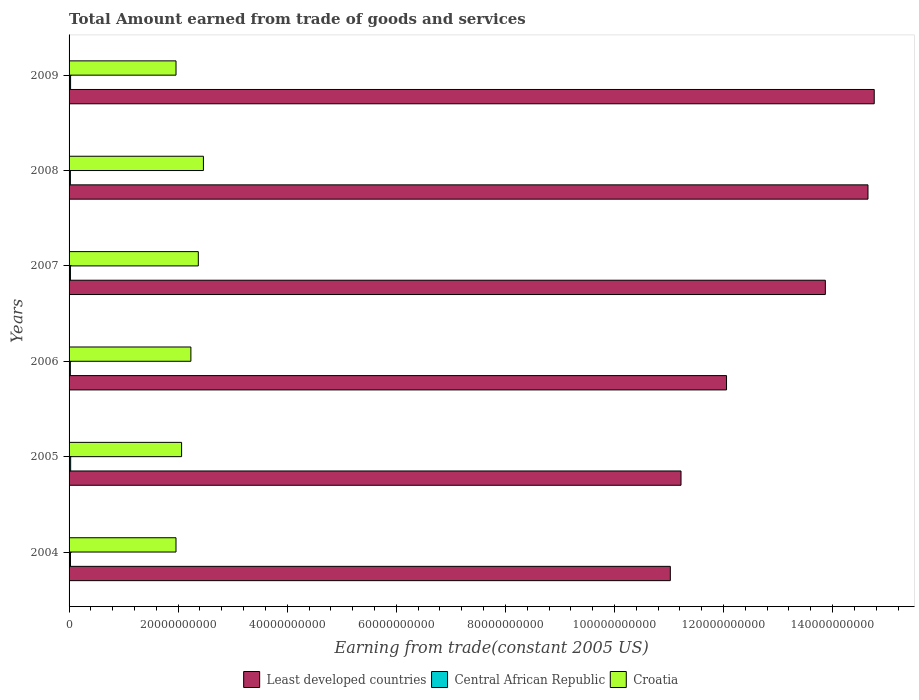How many groups of bars are there?
Your answer should be very brief. 6. How many bars are there on the 6th tick from the bottom?
Your answer should be compact. 3. In how many cases, is the number of bars for a given year not equal to the number of legend labels?
Give a very brief answer. 0. What is the total amount earned by trading goods and services in Central African Republic in 2009?
Ensure brevity in your answer.  2.77e+08. Across all years, what is the maximum total amount earned by trading goods and services in Least developed countries?
Keep it short and to the point. 1.48e+11. Across all years, what is the minimum total amount earned by trading goods and services in Least developed countries?
Ensure brevity in your answer.  1.10e+11. In which year was the total amount earned by trading goods and services in Least developed countries maximum?
Make the answer very short. 2009. In which year was the total amount earned by trading goods and services in Central African Republic minimum?
Keep it short and to the point. 2006. What is the total total amount earned by trading goods and services in Least developed countries in the graph?
Your response must be concise. 7.76e+11. What is the difference between the total amount earned by trading goods and services in Central African Republic in 2006 and that in 2008?
Provide a short and direct response. -1.07e+07. What is the difference between the total amount earned by trading goods and services in Croatia in 2004 and the total amount earned by trading goods and services in Central African Republic in 2006?
Provide a short and direct response. 1.94e+1. What is the average total amount earned by trading goods and services in Least developed countries per year?
Provide a short and direct response. 1.29e+11. In the year 2008, what is the difference between the total amount earned by trading goods and services in Central African Republic and total amount earned by trading goods and services in Least developed countries?
Keep it short and to the point. -1.46e+11. What is the ratio of the total amount earned by trading goods and services in Least developed countries in 2007 to that in 2008?
Ensure brevity in your answer.  0.95. What is the difference between the highest and the second highest total amount earned by trading goods and services in Croatia?
Offer a very short reply. 9.38e+08. What is the difference between the highest and the lowest total amount earned by trading goods and services in Croatia?
Provide a succinct answer. 5.03e+09. In how many years, is the total amount earned by trading goods and services in Central African Republic greater than the average total amount earned by trading goods and services in Central African Republic taken over all years?
Offer a very short reply. 2. Is the sum of the total amount earned by trading goods and services in Least developed countries in 2004 and 2007 greater than the maximum total amount earned by trading goods and services in Croatia across all years?
Offer a terse response. Yes. What does the 1st bar from the top in 2005 represents?
Keep it short and to the point. Croatia. What does the 2nd bar from the bottom in 2007 represents?
Make the answer very short. Central African Republic. How many bars are there?
Your answer should be very brief. 18. Are all the bars in the graph horizontal?
Offer a terse response. Yes. What is the difference between two consecutive major ticks on the X-axis?
Provide a succinct answer. 2.00e+1. Are the values on the major ticks of X-axis written in scientific E-notation?
Ensure brevity in your answer.  No. Does the graph contain any zero values?
Give a very brief answer. No. Where does the legend appear in the graph?
Provide a short and direct response. Bottom center. What is the title of the graph?
Offer a terse response. Total Amount earned from trade of goods and services. What is the label or title of the X-axis?
Your answer should be compact. Earning from trade(constant 2005 US). What is the label or title of the Y-axis?
Your answer should be compact. Years. What is the Earning from trade(constant 2005 US) in Least developed countries in 2004?
Offer a very short reply. 1.10e+11. What is the Earning from trade(constant 2005 US) in Central African Republic in 2004?
Provide a succinct answer. 2.58e+08. What is the Earning from trade(constant 2005 US) in Croatia in 2004?
Offer a very short reply. 1.96e+1. What is the Earning from trade(constant 2005 US) of Least developed countries in 2005?
Offer a terse response. 1.12e+11. What is the Earning from trade(constant 2005 US) in Central African Republic in 2005?
Offer a very short reply. 2.90e+08. What is the Earning from trade(constant 2005 US) of Croatia in 2005?
Give a very brief answer. 2.06e+1. What is the Earning from trade(constant 2005 US) in Least developed countries in 2006?
Your response must be concise. 1.21e+11. What is the Earning from trade(constant 2005 US) in Central African Republic in 2006?
Provide a short and direct response. 2.32e+08. What is the Earning from trade(constant 2005 US) of Croatia in 2006?
Provide a succinct answer. 2.23e+1. What is the Earning from trade(constant 2005 US) of Least developed countries in 2007?
Keep it short and to the point. 1.39e+11. What is the Earning from trade(constant 2005 US) in Central African Republic in 2007?
Offer a terse response. 2.49e+08. What is the Earning from trade(constant 2005 US) of Croatia in 2007?
Give a very brief answer. 2.37e+1. What is the Earning from trade(constant 2005 US) of Least developed countries in 2008?
Your answer should be compact. 1.46e+11. What is the Earning from trade(constant 2005 US) of Central African Republic in 2008?
Your response must be concise. 2.43e+08. What is the Earning from trade(constant 2005 US) in Croatia in 2008?
Your answer should be very brief. 2.46e+1. What is the Earning from trade(constant 2005 US) of Least developed countries in 2009?
Your answer should be compact. 1.48e+11. What is the Earning from trade(constant 2005 US) in Central African Republic in 2009?
Provide a short and direct response. 2.77e+08. What is the Earning from trade(constant 2005 US) in Croatia in 2009?
Make the answer very short. 1.96e+1. Across all years, what is the maximum Earning from trade(constant 2005 US) of Least developed countries?
Offer a very short reply. 1.48e+11. Across all years, what is the maximum Earning from trade(constant 2005 US) in Central African Republic?
Keep it short and to the point. 2.90e+08. Across all years, what is the maximum Earning from trade(constant 2005 US) in Croatia?
Your answer should be compact. 2.46e+1. Across all years, what is the minimum Earning from trade(constant 2005 US) in Least developed countries?
Provide a succinct answer. 1.10e+11. Across all years, what is the minimum Earning from trade(constant 2005 US) in Central African Republic?
Your response must be concise. 2.32e+08. Across all years, what is the minimum Earning from trade(constant 2005 US) in Croatia?
Keep it short and to the point. 1.96e+1. What is the total Earning from trade(constant 2005 US) of Least developed countries in the graph?
Your answer should be very brief. 7.76e+11. What is the total Earning from trade(constant 2005 US) of Central African Republic in the graph?
Make the answer very short. 1.55e+09. What is the total Earning from trade(constant 2005 US) in Croatia in the graph?
Offer a very short reply. 1.31e+11. What is the difference between the Earning from trade(constant 2005 US) in Least developed countries in 2004 and that in 2005?
Give a very brief answer. -1.96e+09. What is the difference between the Earning from trade(constant 2005 US) of Central African Republic in 2004 and that in 2005?
Your answer should be compact. -3.28e+07. What is the difference between the Earning from trade(constant 2005 US) in Croatia in 2004 and that in 2005?
Your answer should be compact. -1.03e+09. What is the difference between the Earning from trade(constant 2005 US) of Least developed countries in 2004 and that in 2006?
Make the answer very short. -1.03e+1. What is the difference between the Earning from trade(constant 2005 US) in Central African Republic in 2004 and that in 2006?
Offer a terse response. 2.55e+07. What is the difference between the Earning from trade(constant 2005 US) of Croatia in 2004 and that in 2006?
Make the answer very short. -2.73e+09. What is the difference between the Earning from trade(constant 2005 US) of Least developed countries in 2004 and that in 2007?
Offer a very short reply. -2.84e+1. What is the difference between the Earning from trade(constant 2005 US) of Central African Republic in 2004 and that in 2007?
Your answer should be compact. 8.05e+06. What is the difference between the Earning from trade(constant 2005 US) in Croatia in 2004 and that in 2007?
Make the answer very short. -4.09e+09. What is the difference between the Earning from trade(constant 2005 US) in Least developed countries in 2004 and that in 2008?
Your response must be concise. -3.62e+1. What is the difference between the Earning from trade(constant 2005 US) of Central African Republic in 2004 and that in 2008?
Your response must be concise. 1.48e+07. What is the difference between the Earning from trade(constant 2005 US) of Croatia in 2004 and that in 2008?
Ensure brevity in your answer.  -5.03e+09. What is the difference between the Earning from trade(constant 2005 US) of Least developed countries in 2004 and that in 2009?
Your answer should be compact. -3.74e+1. What is the difference between the Earning from trade(constant 2005 US) of Central African Republic in 2004 and that in 2009?
Provide a short and direct response. -1.94e+07. What is the difference between the Earning from trade(constant 2005 US) in Croatia in 2004 and that in 2009?
Offer a very short reply. -5.06e+06. What is the difference between the Earning from trade(constant 2005 US) of Least developed countries in 2005 and that in 2006?
Make the answer very short. -8.35e+09. What is the difference between the Earning from trade(constant 2005 US) of Central African Republic in 2005 and that in 2006?
Your answer should be compact. 5.83e+07. What is the difference between the Earning from trade(constant 2005 US) in Croatia in 2005 and that in 2006?
Provide a short and direct response. -1.70e+09. What is the difference between the Earning from trade(constant 2005 US) in Least developed countries in 2005 and that in 2007?
Your answer should be compact. -2.65e+1. What is the difference between the Earning from trade(constant 2005 US) in Central African Republic in 2005 and that in 2007?
Give a very brief answer. 4.08e+07. What is the difference between the Earning from trade(constant 2005 US) of Croatia in 2005 and that in 2007?
Provide a succinct answer. -3.06e+09. What is the difference between the Earning from trade(constant 2005 US) of Least developed countries in 2005 and that in 2008?
Offer a terse response. -3.43e+1. What is the difference between the Earning from trade(constant 2005 US) of Central African Republic in 2005 and that in 2008?
Your answer should be very brief. 4.76e+07. What is the difference between the Earning from trade(constant 2005 US) in Croatia in 2005 and that in 2008?
Your response must be concise. -4.00e+09. What is the difference between the Earning from trade(constant 2005 US) in Least developed countries in 2005 and that in 2009?
Keep it short and to the point. -3.54e+1. What is the difference between the Earning from trade(constant 2005 US) in Central African Republic in 2005 and that in 2009?
Give a very brief answer. 1.34e+07. What is the difference between the Earning from trade(constant 2005 US) of Croatia in 2005 and that in 2009?
Your answer should be compact. 1.02e+09. What is the difference between the Earning from trade(constant 2005 US) in Least developed countries in 2006 and that in 2007?
Your response must be concise. -1.81e+1. What is the difference between the Earning from trade(constant 2005 US) of Central African Republic in 2006 and that in 2007?
Provide a short and direct response. -1.75e+07. What is the difference between the Earning from trade(constant 2005 US) of Croatia in 2006 and that in 2007?
Provide a succinct answer. -1.36e+09. What is the difference between the Earning from trade(constant 2005 US) in Least developed countries in 2006 and that in 2008?
Provide a short and direct response. -2.59e+1. What is the difference between the Earning from trade(constant 2005 US) in Central African Republic in 2006 and that in 2008?
Give a very brief answer. -1.07e+07. What is the difference between the Earning from trade(constant 2005 US) of Croatia in 2006 and that in 2008?
Ensure brevity in your answer.  -2.30e+09. What is the difference between the Earning from trade(constant 2005 US) in Least developed countries in 2006 and that in 2009?
Offer a terse response. -2.71e+1. What is the difference between the Earning from trade(constant 2005 US) of Central African Republic in 2006 and that in 2009?
Keep it short and to the point. -4.49e+07. What is the difference between the Earning from trade(constant 2005 US) in Croatia in 2006 and that in 2009?
Offer a very short reply. 2.73e+09. What is the difference between the Earning from trade(constant 2005 US) in Least developed countries in 2007 and that in 2008?
Keep it short and to the point. -7.82e+09. What is the difference between the Earning from trade(constant 2005 US) of Central African Republic in 2007 and that in 2008?
Offer a terse response. 6.75e+06. What is the difference between the Earning from trade(constant 2005 US) in Croatia in 2007 and that in 2008?
Give a very brief answer. -9.38e+08. What is the difference between the Earning from trade(constant 2005 US) of Least developed countries in 2007 and that in 2009?
Your answer should be compact. -8.96e+09. What is the difference between the Earning from trade(constant 2005 US) of Central African Republic in 2007 and that in 2009?
Make the answer very short. -2.74e+07. What is the difference between the Earning from trade(constant 2005 US) in Croatia in 2007 and that in 2009?
Ensure brevity in your answer.  4.09e+09. What is the difference between the Earning from trade(constant 2005 US) in Least developed countries in 2008 and that in 2009?
Give a very brief answer. -1.15e+09. What is the difference between the Earning from trade(constant 2005 US) of Central African Republic in 2008 and that in 2009?
Your answer should be very brief. -3.42e+07. What is the difference between the Earning from trade(constant 2005 US) of Croatia in 2008 and that in 2009?
Ensure brevity in your answer.  5.02e+09. What is the difference between the Earning from trade(constant 2005 US) of Least developed countries in 2004 and the Earning from trade(constant 2005 US) of Central African Republic in 2005?
Give a very brief answer. 1.10e+11. What is the difference between the Earning from trade(constant 2005 US) of Least developed countries in 2004 and the Earning from trade(constant 2005 US) of Croatia in 2005?
Offer a terse response. 8.96e+1. What is the difference between the Earning from trade(constant 2005 US) of Central African Republic in 2004 and the Earning from trade(constant 2005 US) of Croatia in 2005?
Your response must be concise. -2.04e+1. What is the difference between the Earning from trade(constant 2005 US) of Least developed countries in 2004 and the Earning from trade(constant 2005 US) of Central African Republic in 2006?
Make the answer very short. 1.10e+11. What is the difference between the Earning from trade(constant 2005 US) in Least developed countries in 2004 and the Earning from trade(constant 2005 US) in Croatia in 2006?
Your answer should be very brief. 8.79e+1. What is the difference between the Earning from trade(constant 2005 US) in Central African Republic in 2004 and the Earning from trade(constant 2005 US) in Croatia in 2006?
Make the answer very short. -2.21e+1. What is the difference between the Earning from trade(constant 2005 US) of Least developed countries in 2004 and the Earning from trade(constant 2005 US) of Central African Republic in 2007?
Make the answer very short. 1.10e+11. What is the difference between the Earning from trade(constant 2005 US) of Least developed countries in 2004 and the Earning from trade(constant 2005 US) of Croatia in 2007?
Provide a succinct answer. 8.66e+1. What is the difference between the Earning from trade(constant 2005 US) in Central African Republic in 2004 and the Earning from trade(constant 2005 US) in Croatia in 2007?
Give a very brief answer. -2.34e+1. What is the difference between the Earning from trade(constant 2005 US) of Least developed countries in 2004 and the Earning from trade(constant 2005 US) of Central African Republic in 2008?
Your response must be concise. 1.10e+11. What is the difference between the Earning from trade(constant 2005 US) in Least developed countries in 2004 and the Earning from trade(constant 2005 US) in Croatia in 2008?
Your answer should be very brief. 8.56e+1. What is the difference between the Earning from trade(constant 2005 US) in Central African Republic in 2004 and the Earning from trade(constant 2005 US) in Croatia in 2008?
Provide a succinct answer. -2.44e+1. What is the difference between the Earning from trade(constant 2005 US) of Least developed countries in 2004 and the Earning from trade(constant 2005 US) of Central African Republic in 2009?
Provide a succinct answer. 1.10e+11. What is the difference between the Earning from trade(constant 2005 US) of Least developed countries in 2004 and the Earning from trade(constant 2005 US) of Croatia in 2009?
Keep it short and to the point. 9.06e+1. What is the difference between the Earning from trade(constant 2005 US) in Central African Republic in 2004 and the Earning from trade(constant 2005 US) in Croatia in 2009?
Provide a short and direct response. -1.94e+1. What is the difference between the Earning from trade(constant 2005 US) in Least developed countries in 2005 and the Earning from trade(constant 2005 US) in Central African Republic in 2006?
Keep it short and to the point. 1.12e+11. What is the difference between the Earning from trade(constant 2005 US) of Least developed countries in 2005 and the Earning from trade(constant 2005 US) of Croatia in 2006?
Your answer should be compact. 8.99e+1. What is the difference between the Earning from trade(constant 2005 US) in Central African Republic in 2005 and the Earning from trade(constant 2005 US) in Croatia in 2006?
Ensure brevity in your answer.  -2.20e+1. What is the difference between the Earning from trade(constant 2005 US) of Least developed countries in 2005 and the Earning from trade(constant 2005 US) of Central African Republic in 2007?
Your answer should be very brief. 1.12e+11. What is the difference between the Earning from trade(constant 2005 US) in Least developed countries in 2005 and the Earning from trade(constant 2005 US) in Croatia in 2007?
Offer a terse response. 8.85e+1. What is the difference between the Earning from trade(constant 2005 US) in Central African Republic in 2005 and the Earning from trade(constant 2005 US) in Croatia in 2007?
Provide a succinct answer. -2.34e+1. What is the difference between the Earning from trade(constant 2005 US) in Least developed countries in 2005 and the Earning from trade(constant 2005 US) in Central African Republic in 2008?
Make the answer very short. 1.12e+11. What is the difference between the Earning from trade(constant 2005 US) in Least developed countries in 2005 and the Earning from trade(constant 2005 US) in Croatia in 2008?
Your answer should be compact. 8.76e+1. What is the difference between the Earning from trade(constant 2005 US) in Central African Republic in 2005 and the Earning from trade(constant 2005 US) in Croatia in 2008?
Make the answer very short. -2.43e+1. What is the difference between the Earning from trade(constant 2005 US) of Least developed countries in 2005 and the Earning from trade(constant 2005 US) of Central African Republic in 2009?
Keep it short and to the point. 1.12e+11. What is the difference between the Earning from trade(constant 2005 US) of Least developed countries in 2005 and the Earning from trade(constant 2005 US) of Croatia in 2009?
Your response must be concise. 9.26e+1. What is the difference between the Earning from trade(constant 2005 US) in Central African Republic in 2005 and the Earning from trade(constant 2005 US) in Croatia in 2009?
Your answer should be compact. -1.93e+1. What is the difference between the Earning from trade(constant 2005 US) in Least developed countries in 2006 and the Earning from trade(constant 2005 US) in Central African Republic in 2007?
Your answer should be very brief. 1.20e+11. What is the difference between the Earning from trade(constant 2005 US) of Least developed countries in 2006 and the Earning from trade(constant 2005 US) of Croatia in 2007?
Your answer should be compact. 9.69e+1. What is the difference between the Earning from trade(constant 2005 US) in Central African Republic in 2006 and the Earning from trade(constant 2005 US) in Croatia in 2007?
Your answer should be compact. -2.35e+1. What is the difference between the Earning from trade(constant 2005 US) of Least developed countries in 2006 and the Earning from trade(constant 2005 US) of Central African Republic in 2008?
Your answer should be compact. 1.20e+11. What is the difference between the Earning from trade(constant 2005 US) of Least developed countries in 2006 and the Earning from trade(constant 2005 US) of Croatia in 2008?
Offer a terse response. 9.59e+1. What is the difference between the Earning from trade(constant 2005 US) in Central African Republic in 2006 and the Earning from trade(constant 2005 US) in Croatia in 2008?
Keep it short and to the point. -2.44e+1. What is the difference between the Earning from trade(constant 2005 US) in Least developed countries in 2006 and the Earning from trade(constant 2005 US) in Central African Republic in 2009?
Your response must be concise. 1.20e+11. What is the difference between the Earning from trade(constant 2005 US) of Least developed countries in 2006 and the Earning from trade(constant 2005 US) of Croatia in 2009?
Ensure brevity in your answer.  1.01e+11. What is the difference between the Earning from trade(constant 2005 US) of Central African Republic in 2006 and the Earning from trade(constant 2005 US) of Croatia in 2009?
Offer a very short reply. -1.94e+1. What is the difference between the Earning from trade(constant 2005 US) of Least developed countries in 2007 and the Earning from trade(constant 2005 US) of Central African Republic in 2008?
Offer a very short reply. 1.38e+11. What is the difference between the Earning from trade(constant 2005 US) of Least developed countries in 2007 and the Earning from trade(constant 2005 US) of Croatia in 2008?
Your response must be concise. 1.14e+11. What is the difference between the Earning from trade(constant 2005 US) of Central African Republic in 2007 and the Earning from trade(constant 2005 US) of Croatia in 2008?
Your answer should be very brief. -2.44e+1. What is the difference between the Earning from trade(constant 2005 US) in Least developed countries in 2007 and the Earning from trade(constant 2005 US) in Central African Republic in 2009?
Keep it short and to the point. 1.38e+11. What is the difference between the Earning from trade(constant 2005 US) in Least developed countries in 2007 and the Earning from trade(constant 2005 US) in Croatia in 2009?
Your answer should be very brief. 1.19e+11. What is the difference between the Earning from trade(constant 2005 US) of Central African Republic in 2007 and the Earning from trade(constant 2005 US) of Croatia in 2009?
Your answer should be very brief. -1.94e+1. What is the difference between the Earning from trade(constant 2005 US) in Least developed countries in 2008 and the Earning from trade(constant 2005 US) in Central African Republic in 2009?
Your answer should be compact. 1.46e+11. What is the difference between the Earning from trade(constant 2005 US) of Least developed countries in 2008 and the Earning from trade(constant 2005 US) of Croatia in 2009?
Your answer should be compact. 1.27e+11. What is the difference between the Earning from trade(constant 2005 US) of Central African Republic in 2008 and the Earning from trade(constant 2005 US) of Croatia in 2009?
Offer a terse response. -1.94e+1. What is the average Earning from trade(constant 2005 US) of Least developed countries per year?
Provide a short and direct response. 1.29e+11. What is the average Earning from trade(constant 2005 US) of Central African Republic per year?
Give a very brief answer. 2.58e+08. What is the average Earning from trade(constant 2005 US) in Croatia per year?
Provide a succinct answer. 2.18e+1. In the year 2004, what is the difference between the Earning from trade(constant 2005 US) of Least developed countries and Earning from trade(constant 2005 US) of Central African Republic?
Your answer should be very brief. 1.10e+11. In the year 2004, what is the difference between the Earning from trade(constant 2005 US) in Least developed countries and Earning from trade(constant 2005 US) in Croatia?
Your answer should be compact. 9.06e+1. In the year 2004, what is the difference between the Earning from trade(constant 2005 US) in Central African Republic and Earning from trade(constant 2005 US) in Croatia?
Your answer should be compact. -1.93e+1. In the year 2005, what is the difference between the Earning from trade(constant 2005 US) of Least developed countries and Earning from trade(constant 2005 US) of Central African Republic?
Your answer should be compact. 1.12e+11. In the year 2005, what is the difference between the Earning from trade(constant 2005 US) of Least developed countries and Earning from trade(constant 2005 US) of Croatia?
Keep it short and to the point. 9.16e+1. In the year 2005, what is the difference between the Earning from trade(constant 2005 US) in Central African Republic and Earning from trade(constant 2005 US) in Croatia?
Offer a very short reply. -2.03e+1. In the year 2006, what is the difference between the Earning from trade(constant 2005 US) in Least developed countries and Earning from trade(constant 2005 US) in Central African Republic?
Provide a short and direct response. 1.20e+11. In the year 2006, what is the difference between the Earning from trade(constant 2005 US) in Least developed countries and Earning from trade(constant 2005 US) in Croatia?
Your answer should be very brief. 9.82e+1. In the year 2006, what is the difference between the Earning from trade(constant 2005 US) of Central African Republic and Earning from trade(constant 2005 US) of Croatia?
Your answer should be very brief. -2.21e+1. In the year 2007, what is the difference between the Earning from trade(constant 2005 US) of Least developed countries and Earning from trade(constant 2005 US) of Central African Republic?
Offer a terse response. 1.38e+11. In the year 2007, what is the difference between the Earning from trade(constant 2005 US) of Least developed countries and Earning from trade(constant 2005 US) of Croatia?
Offer a very short reply. 1.15e+11. In the year 2007, what is the difference between the Earning from trade(constant 2005 US) in Central African Republic and Earning from trade(constant 2005 US) in Croatia?
Your response must be concise. -2.34e+1. In the year 2008, what is the difference between the Earning from trade(constant 2005 US) of Least developed countries and Earning from trade(constant 2005 US) of Central African Republic?
Ensure brevity in your answer.  1.46e+11. In the year 2008, what is the difference between the Earning from trade(constant 2005 US) of Least developed countries and Earning from trade(constant 2005 US) of Croatia?
Provide a short and direct response. 1.22e+11. In the year 2008, what is the difference between the Earning from trade(constant 2005 US) in Central African Republic and Earning from trade(constant 2005 US) in Croatia?
Offer a terse response. -2.44e+1. In the year 2009, what is the difference between the Earning from trade(constant 2005 US) of Least developed countries and Earning from trade(constant 2005 US) of Central African Republic?
Ensure brevity in your answer.  1.47e+11. In the year 2009, what is the difference between the Earning from trade(constant 2005 US) of Least developed countries and Earning from trade(constant 2005 US) of Croatia?
Your answer should be very brief. 1.28e+11. In the year 2009, what is the difference between the Earning from trade(constant 2005 US) in Central African Republic and Earning from trade(constant 2005 US) in Croatia?
Offer a very short reply. -1.93e+1. What is the ratio of the Earning from trade(constant 2005 US) in Least developed countries in 2004 to that in 2005?
Ensure brevity in your answer.  0.98. What is the ratio of the Earning from trade(constant 2005 US) in Central African Republic in 2004 to that in 2005?
Offer a terse response. 0.89. What is the ratio of the Earning from trade(constant 2005 US) of Croatia in 2004 to that in 2005?
Your answer should be compact. 0.95. What is the ratio of the Earning from trade(constant 2005 US) in Least developed countries in 2004 to that in 2006?
Make the answer very short. 0.91. What is the ratio of the Earning from trade(constant 2005 US) in Central African Republic in 2004 to that in 2006?
Give a very brief answer. 1.11. What is the ratio of the Earning from trade(constant 2005 US) in Croatia in 2004 to that in 2006?
Make the answer very short. 0.88. What is the ratio of the Earning from trade(constant 2005 US) in Least developed countries in 2004 to that in 2007?
Give a very brief answer. 0.8. What is the ratio of the Earning from trade(constant 2005 US) in Central African Republic in 2004 to that in 2007?
Offer a terse response. 1.03. What is the ratio of the Earning from trade(constant 2005 US) in Croatia in 2004 to that in 2007?
Your answer should be compact. 0.83. What is the ratio of the Earning from trade(constant 2005 US) of Least developed countries in 2004 to that in 2008?
Make the answer very short. 0.75. What is the ratio of the Earning from trade(constant 2005 US) of Central African Republic in 2004 to that in 2008?
Keep it short and to the point. 1.06. What is the ratio of the Earning from trade(constant 2005 US) in Croatia in 2004 to that in 2008?
Make the answer very short. 0.8. What is the ratio of the Earning from trade(constant 2005 US) in Least developed countries in 2004 to that in 2009?
Provide a short and direct response. 0.75. What is the ratio of the Earning from trade(constant 2005 US) of Central African Republic in 2004 to that in 2009?
Offer a very short reply. 0.93. What is the ratio of the Earning from trade(constant 2005 US) of Croatia in 2004 to that in 2009?
Offer a very short reply. 1. What is the ratio of the Earning from trade(constant 2005 US) in Least developed countries in 2005 to that in 2006?
Offer a terse response. 0.93. What is the ratio of the Earning from trade(constant 2005 US) of Central African Republic in 2005 to that in 2006?
Ensure brevity in your answer.  1.25. What is the ratio of the Earning from trade(constant 2005 US) of Croatia in 2005 to that in 2006?
Your answer should be very brief. 0.92. What is the ratio of the Earning from trade(constant 2005 US) of Least developed countries in 2005 to that in 2007?
Ensure brevity in your answer.  0.81. What is the ratio of the Earning from trade(constant 2005 US) in Central African Republic in 2005 to that in 2007?
Your answer should be compact. 1.16. What is the ratio of the Earning from trade(constant 2005 US) of Croatia in 2005 to that in 2007?
Keep it short and to the point. 0.87. What is the ratio of the Earning from trade(constant 2005 US) of Least developed countries in 2005 to that in 2008?
Provide a short and direct response. 0.77. What is the ratio of the Earning from trade(constant 2005 US) of Central African Republic in 2005 to that in 2008?
Your response must be concise. 1.2. What is the ratio of the Earning from trade(constant 2005 US) in Croatia in 2005 to that in 2008?
Your answer should be compact. 0.84. What is the ratio of the Earning from trade(constant 2005 US) in Least developed countries in 2005 to that in 2009?
Ensure brevity in your answer.  0.76. What is the ratio of the Earning from trade(constant 2005 US) of Central African Republic in 2005 to that in 2009?
Provide a short and direct response. 1.05. What is the ratio of the Earning from trade(constant 2005 US) of Croatia in 2005 to that in 2009?
Your answer should be compact. 1.05. What is the ratio of the Earning from trade(constant 2005 US) of Least developed countries in 2006 to that in 2007?
Make the answer very short. 0.87. What is the ratio of the Earning from trade(constant 2005 US) in Central African Republic in 2006 to that in 2007?
Make the answer very short. 0.93. What is the ratio of the Earning from trade(constant 2005 US) in Croatia in 2006 to that in 2007?
Give a very brief answer. 0.94. What is the ratio of the Earning from trade(constant 2005 US) of Least developed countries in 2006 to that in 2008?
Give a very brief answer. 0.82. What is the ratio of the Earning from trade(constant 2005 US) of Central African Republic in 2006 to that in 2008?
Offer a very short reply. 0.96. What is the ratio of the Earning from trade(constant 2005 US) of Croatia in 2006 to that in 2008?
Make the answer very short. 0.91. What is the ratio of the Earning from trade(constant 2005 US) in Least developed countries in 2006 to that in 2009?
Provide a short and direct response. 0.82. What is the ratio of the Earning from trade(constant 2005 US) in Central African Republic in 2006 to that in 2009?
Ensure brevity in your answer.  0.84. What is the ratio of the Earning from trade(constant 2005 US) in Croatia in 2006 to that in 2009?
Provide a succinct answer. 1.14. What is the ratio of the Earning from trade(constant 2005 US) in Least developed countries in 2007 to that in 2008?
Make the answer very short. 0.95. What is the ratio of the Earning from trade(constant 2005 US) of Central African Republic in 2007 to that in 2008?
Your answer should be very brief. 1.03. What is the ratio of the Earning from trade(constant 2005 US) of Croatia in 2007 to that in 2008?
Offer a terse response. 0.96. What is the ratio of the Earning from trade(constant 2005 US) in Least developed countries in 2007 to that in 2009?
Offer a terse response. 0.94. What is the ratio of the Earning from trade(constant 2005 US) in Central African Republic in 2007 to that in 2009?
Ensure brevity in your answer.  0.9. What is the ratio of the Earning from trade(constant 2005 US) in Croatia in 2007 to that in 2009?
Give a very brief answer. 1.21. What is the ratio of the Earning from trade(constant 2005 US) of Least developed countries in 2008 to that in 2009?
Provide a succinct answer. 0.99. What is the ratio of the Earning from trade(constant 2005 US) in Central African Republic in 2008 to that in 2009?
Ensure brevity in your answer.  0.88. What is the ratio of the Earning from trade(constant 2005 US) of Croatia in 2008 to that in 2009?
Keep it short and to the point. 1.26. What is the difference between the highest and the second highest Earning from trade(constant 2005 US) of Least developed countries?
Your response must be concise. 1.15e+09. What is the difference between the highest and the second highest Earning from trade(constant 2005 US) in Central African Republic?
Ensure brevity in your answer.  1.34e+07. What is the difference between the highest and the second highest Earning from trade(constant 2005 US) in Croatia?
Your answer should be compact. 9.38e+08. What is the difference between the highest and the lowest Earning from trade(constant 2005 US) in Least developed countries?
Make the answer very short. 3.74e+1. What is the difference between the highest and the lowest Earning from trade(constant 2005 US) of Central African Republic?
Your response must be concise. 5.83e+07. What is the difference between the highest and the lowest Earning from trade(constant 2005 US) of Croatia?
Make the answer very short. 5.03e+09. 